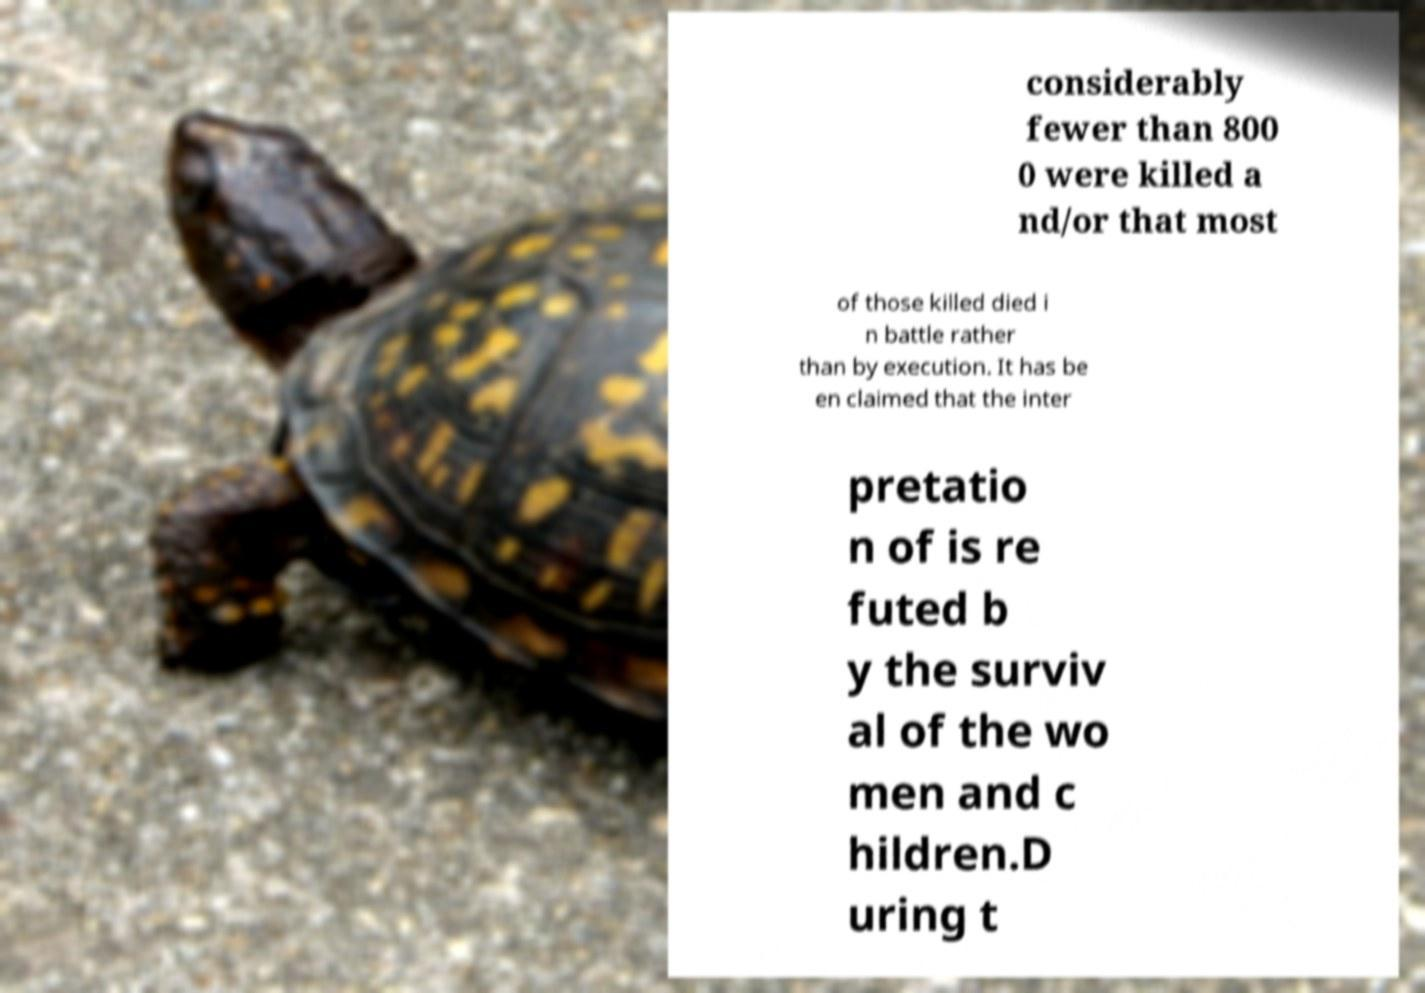Please read and relay the text visible in this image. What does it say? considerably fewer than 800 0 were killed a nd/or that most of those killed died i n battle rather than by execution. It has be en claimed that the inter pretatio n of is re futed b y the surviv al of the wo men and c hildren.D uring t 